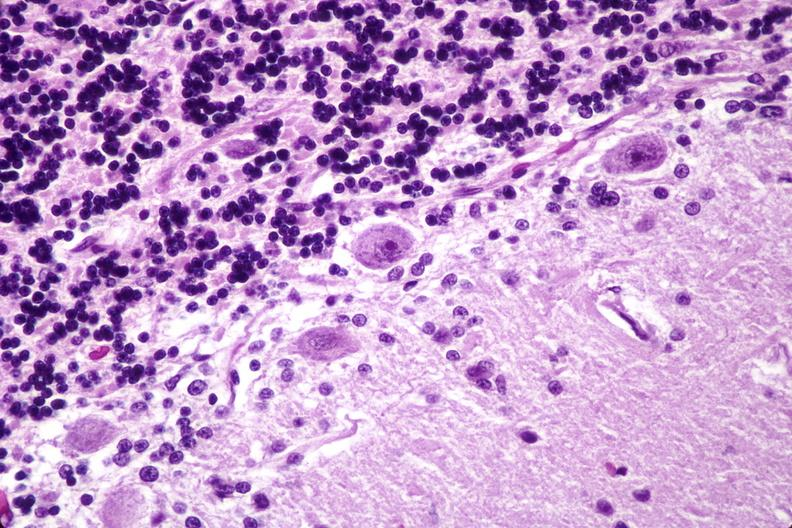s nervous present?
Answer the question using a single word or phrase. Yes 